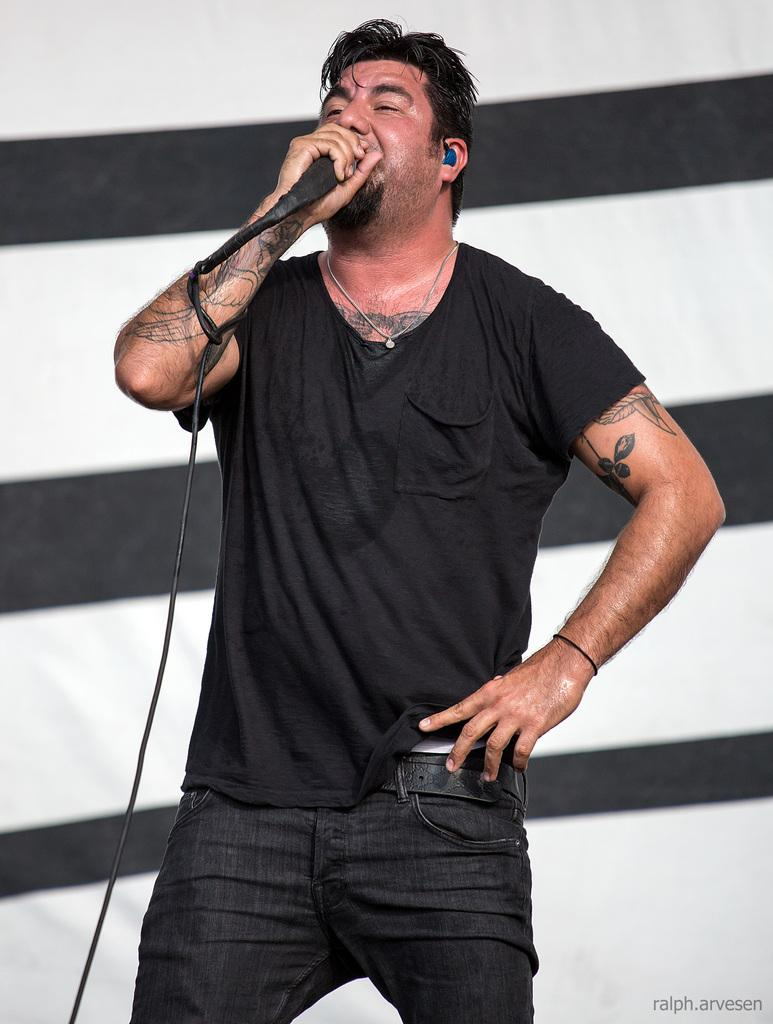What is the main subject of the image? There is a person in the image. What is the person holding in the image? The person is holding a microphone. Can you describe the background in the image? There is a background visible in the image. What is present in the bottom right corner of the image? There is some text in the bottom right corner of the image. How many children are playing with clocks in the image? There are no children or clocks present in the image. 